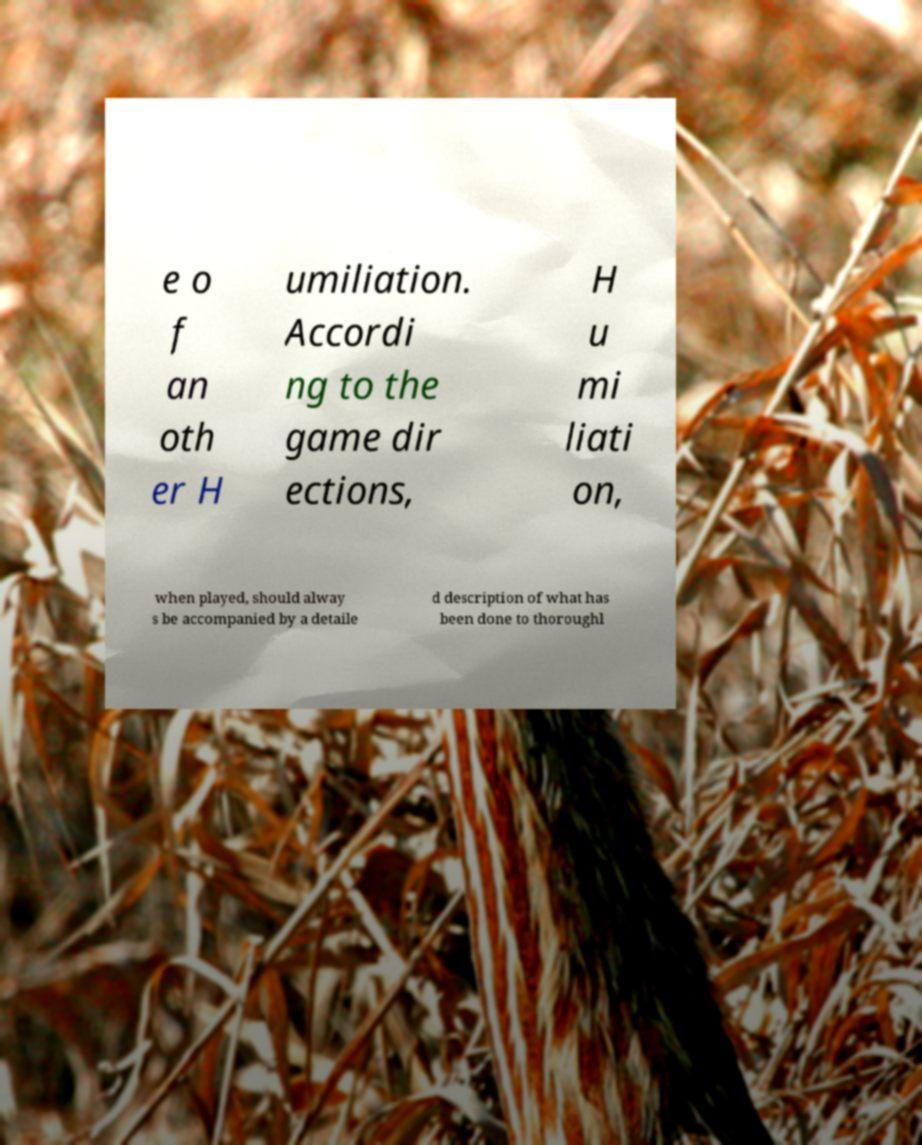Can you read and provide the text displayed in the image?This photo seems to have some interesting text. Can you extract and type it out for me? e o f an oth er H umiliation. Accordi ng to the game dir ections, H u mi liati on, when played, should alway s be accompanied by a detaile d description of what has been done to thoroughl 